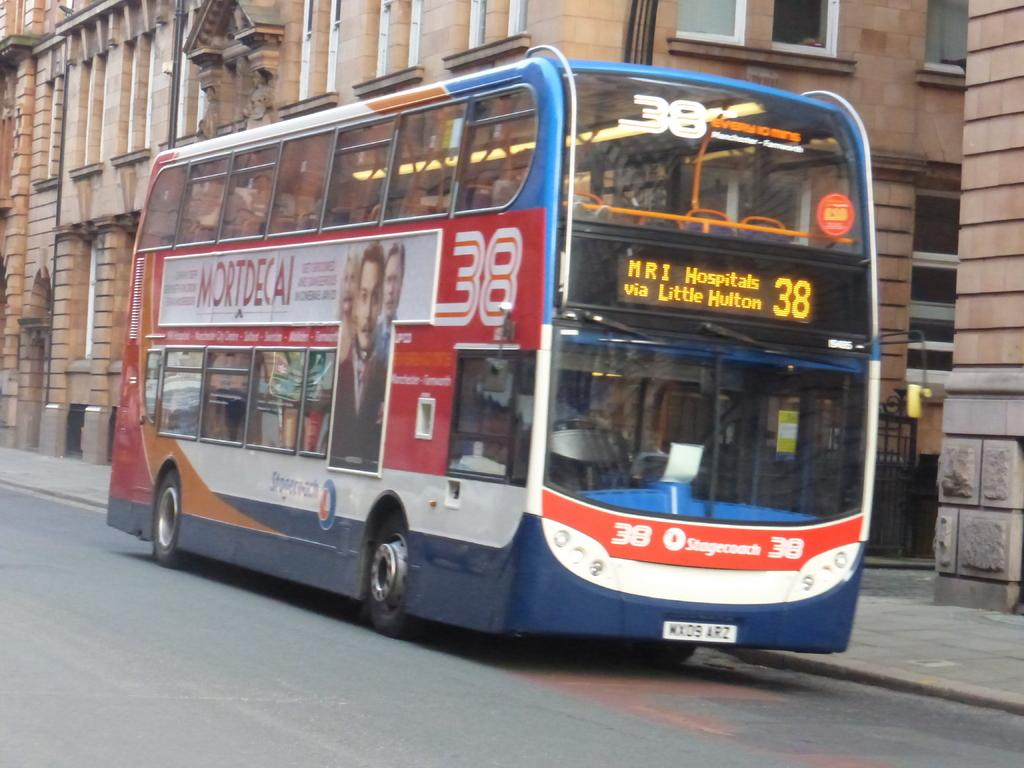What is the main subject of the image? The main subject of the image is a bus. Where is the bus located in the image? The bus is on the road in the image. What can be seen in the background of the image? There is a building and a gate in the background of the image. What type of fiction is the bus reading in the image? The bus is not reading any fiction in the image, as it is a vehicle and not capable of reading. 